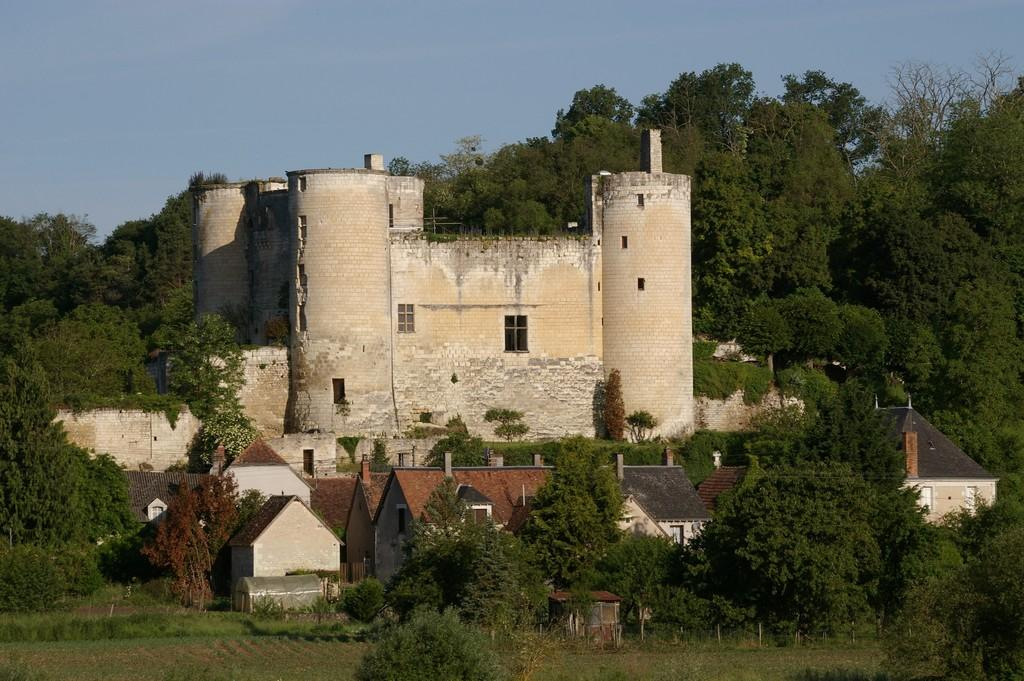What type of structure can be seen in the image? There is a building in the image. Are there any residential structures in the image? Yes, there are houses in the image. What type of vegetation is visible in the image? There is grass and trees visible in the image. What part of the natural environment can be seen in the image? The sky is visible in the image. What architectural feature can be seen in the image? There are windows visible in the image. Can you see any mountains in the image? There are no mountains visible in the image. What type of pest can be seen crawling on the building in the image? There are no pests visible in the image. 